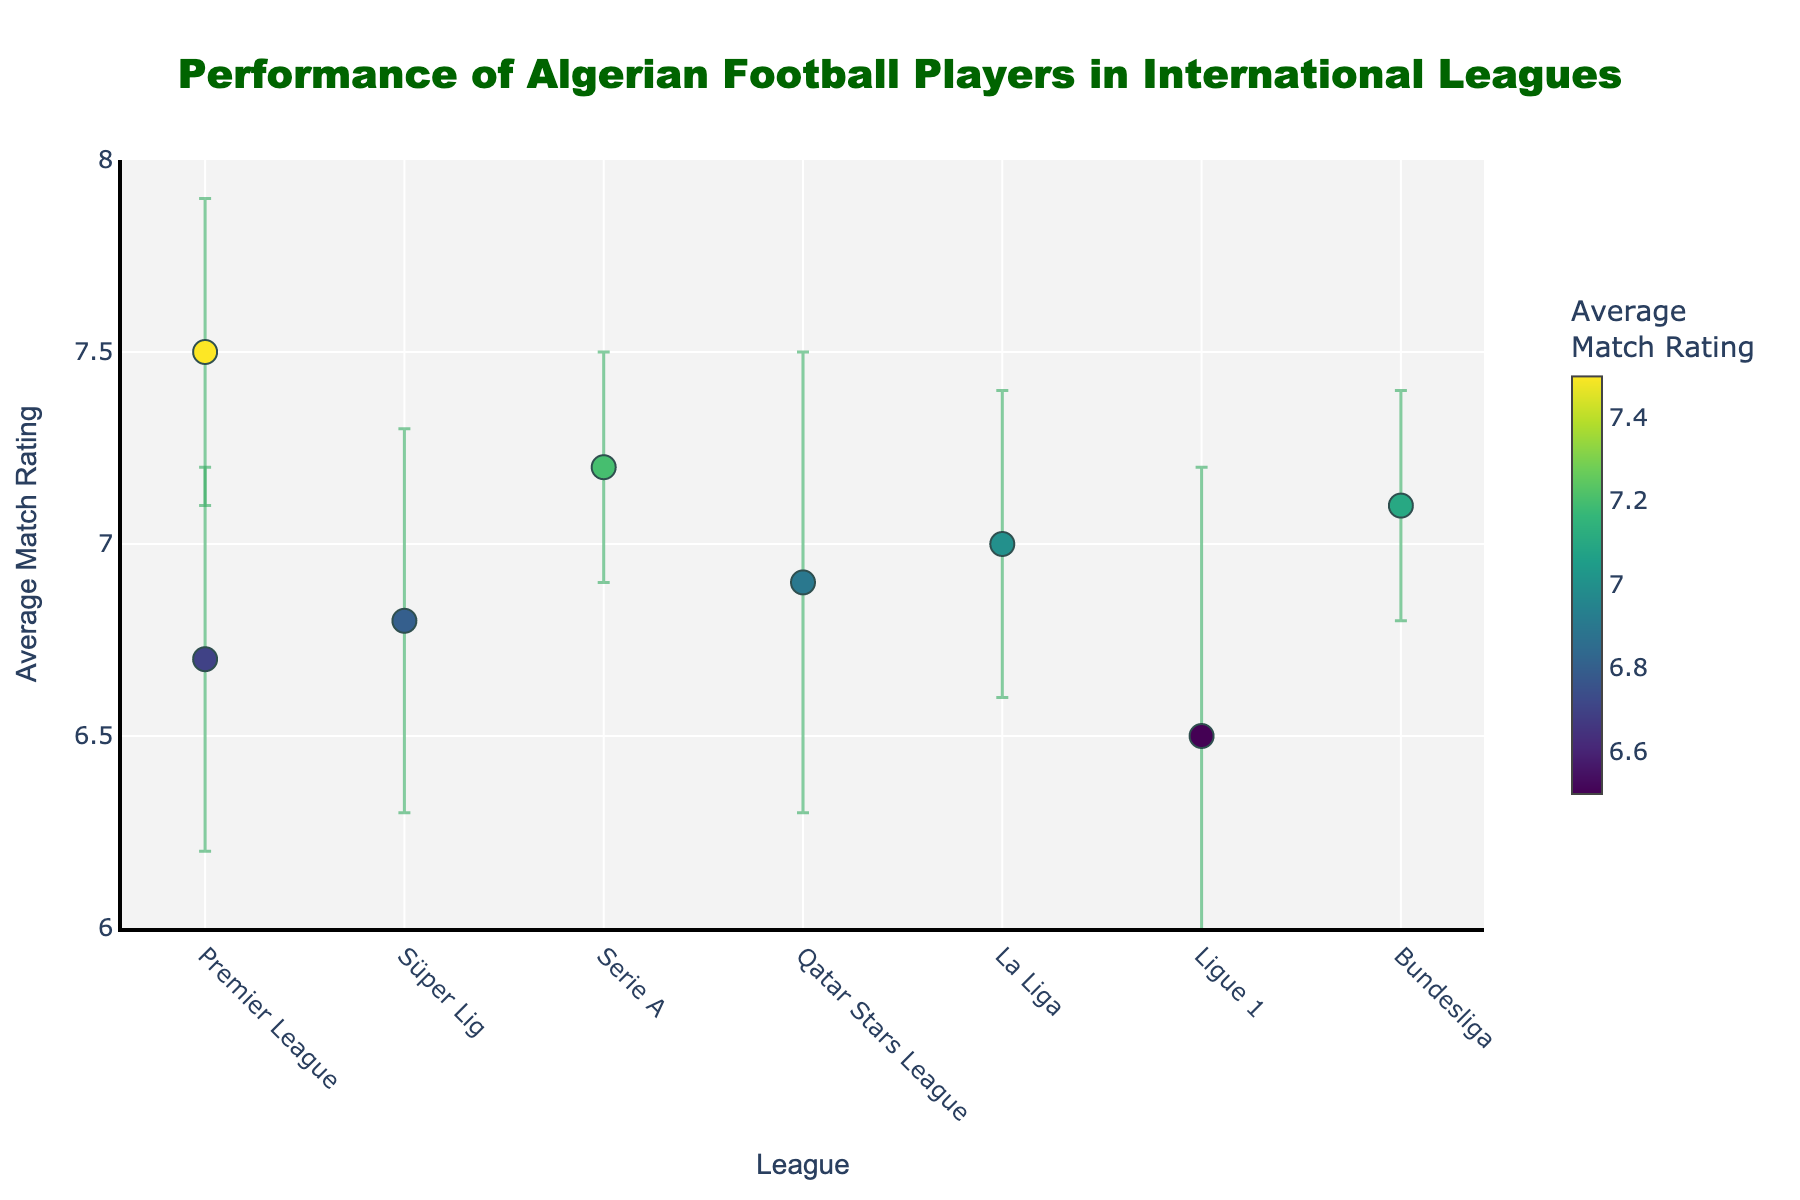Who achieved the highest average match rating? By examining the scatter plot, identify the data point with the highest position on the y-axis. Riyad Mahrez in the Premier League with a rating of 7.5 stands out as the highest.
Answer: Riyad Mahrez Which league has the player with the lowest average match rating? Observe the data points on the y-axis and find the one corresponding to the lowest value. Islam Slimani in Ligue 1 with an average rating of 6.5 appears at the lowest position.
Answer: Ligue 1 What is the average match rating of Ismaël Bennacer? Look at the hover text or the y-axis position of the point labeled 'Ismaël Bennacer.' The rating shown is 7.2.
Answer: 7.2 Who has the highest standard deviation among all players? Check the error bars in the plot. The longest error bar represents the highest standard deviation. Yacine Brahimi, in the Qatar Stars League, has the longest error bar, indicating a standard deviation of 0.6.
Answer: Yacine Brahimi Compare the average match ratings of players in the Premier League. Who performs better? Look at the data points for Premier League players (Riyad Mahrez and Saïd Benrahma) and compare their positions on the y-axis. Riyad Mahrez has a higher average match rating (7.5) compared to Saïd Benrahma (6.7).
Answer: Riyad Mahrez What’s the average of the average match ratings of all players? Sum the average match ratings of all players and divide by the number of players: (7.5 + 6.8 + 7.2 + 6.9 + 7.0 + 6.7 + 6.5 + 7.1) / 8 = 55.7 / 8 = 6.96
Answer: 6.96 How does the performance variability of Ramy Bensebaini compare to Ismaël Bennacer? Compare the lengths of their error bars. Ismaël Bennacer has a standard deviation of 0.3 and Ramy Bensebaini also has a standard deviation of 0.3, indicating similar performance variability.
Answer: similar Which league has the most consistent (less variable) player performance? Identify the shortest error bars in the plot, representing the lowest standard deviations. Both Ramy Bensebaini in the Bundesliga and Ismaël Bennacer in Serie A have the shortest error bars, indicating less performance variability. Both have a standard deviation of 0.3.
Answer: Bundesliga and Serie A Order the leagues based on the average match ratings of their respective Algerian players, from highest to lowest. List the average match ratings from the scatter plot and sort them: Premier League (Mahrez, 7.5), Serie A (Bennacer, 7.2), Bundesliga (Bensebaini, 7.1), La Liga (Mandi, 7.0), Qatar Stars League (Brahimi, 6.9), Süper Lig (Feghouli, 6.8), Premier League (Benrahma, 6.7), Ligue 1 (Slimani, 6.5).
Answer: Premier League (Mahrez), Serie A, Bundesliga, La Liga, Qatar Stars League, Süper Lig, Premier League (Benrahma), Ligue 1 